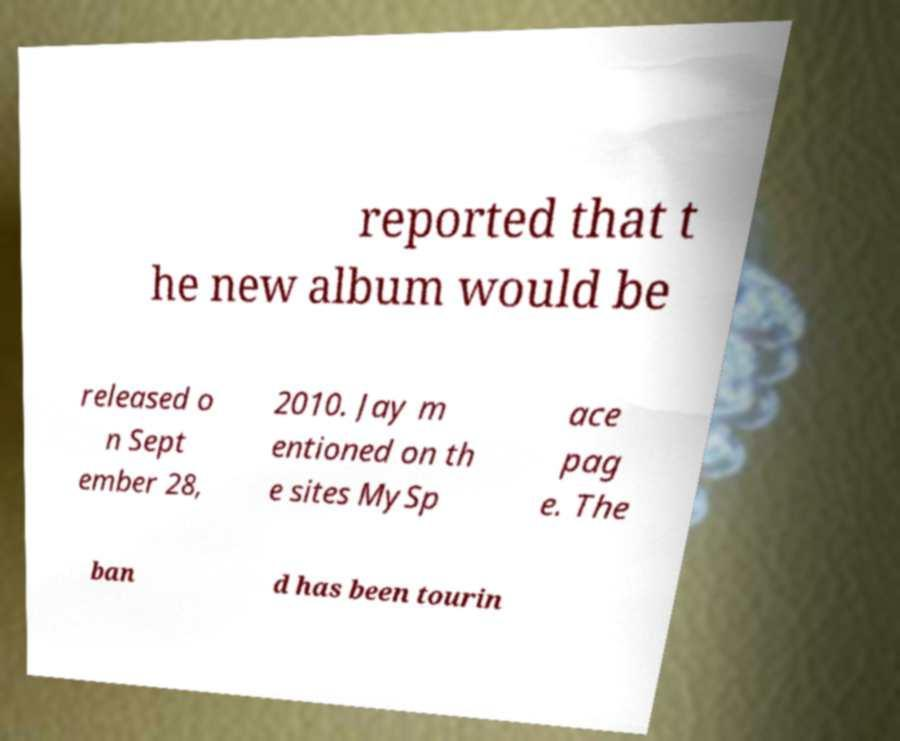Could you assist in decoding the text presented in this image and type it out clearly? reported that t he new album would be released o n Sept ember 28, 2010. Jay m entioned on th e sites MySp ace pag e. The ban d has been tourin 